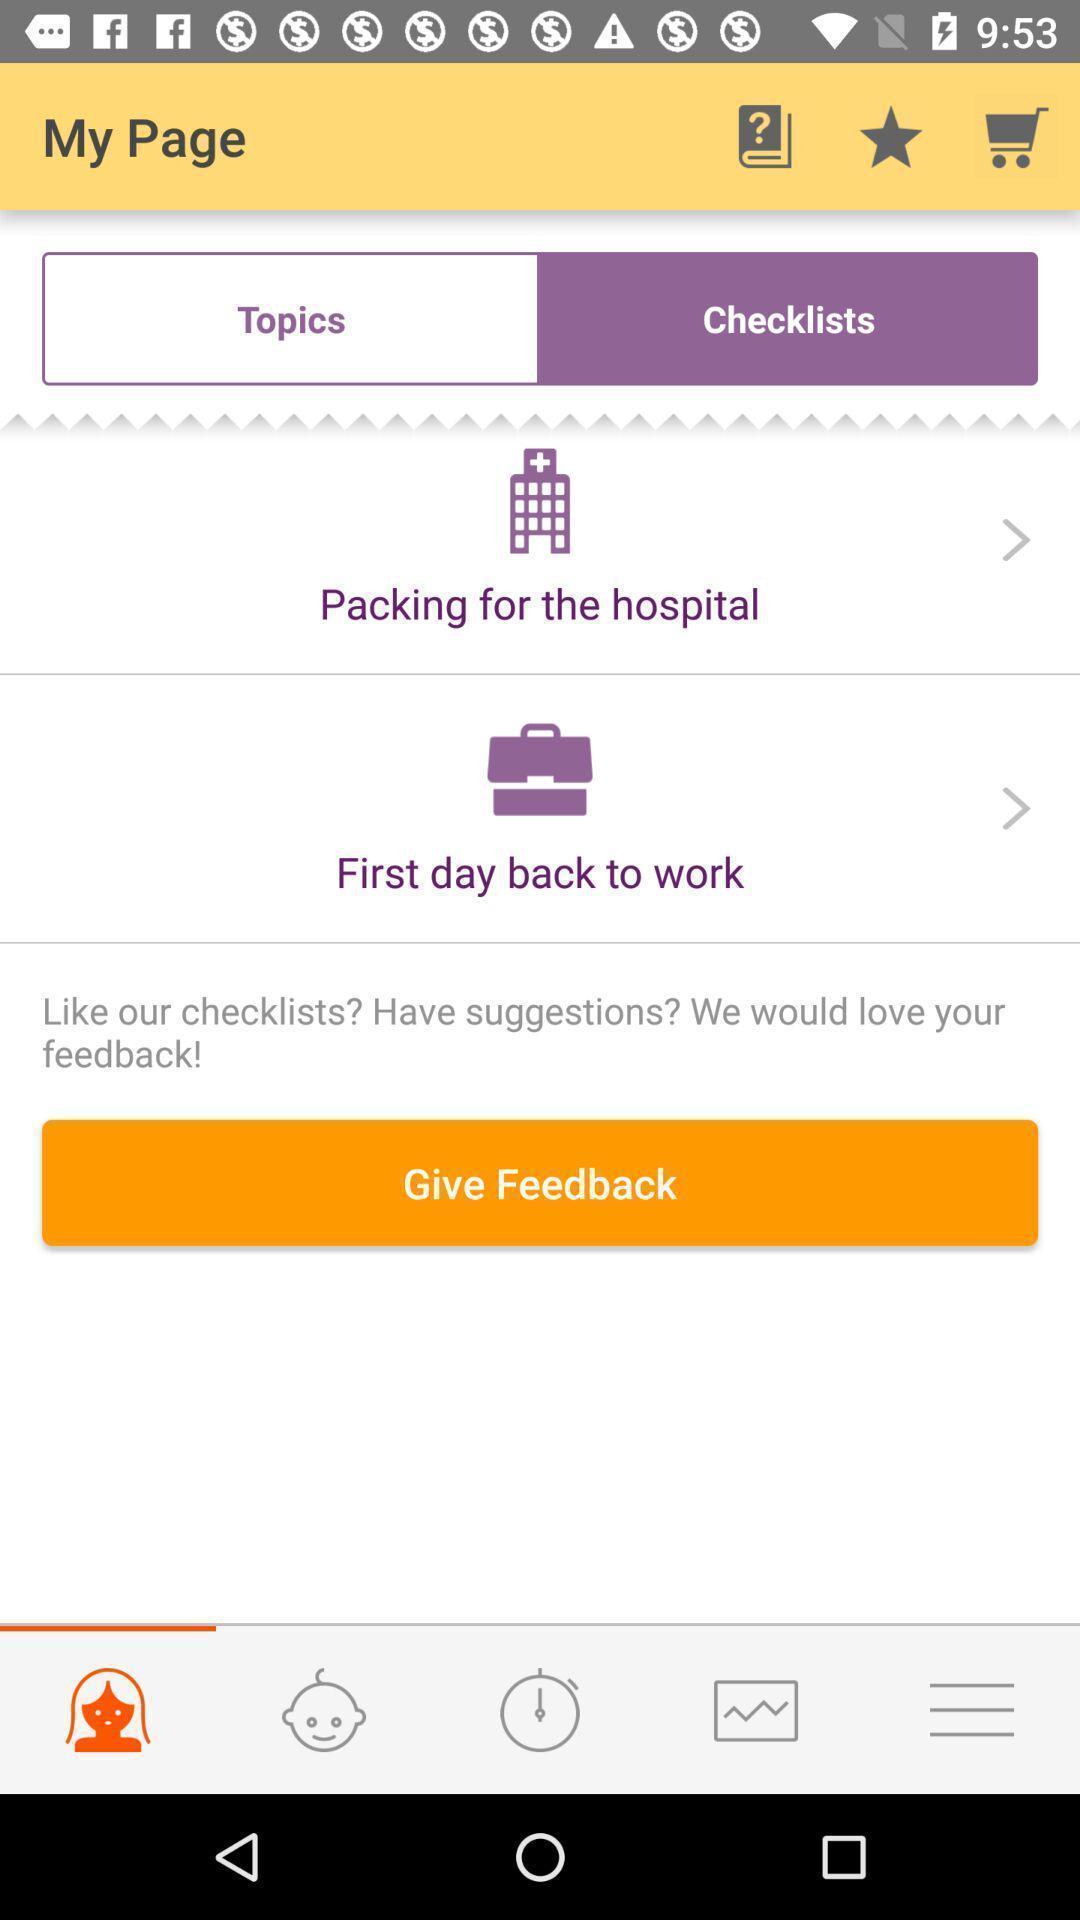What can you discern from this picture? Page with give feedback option. 